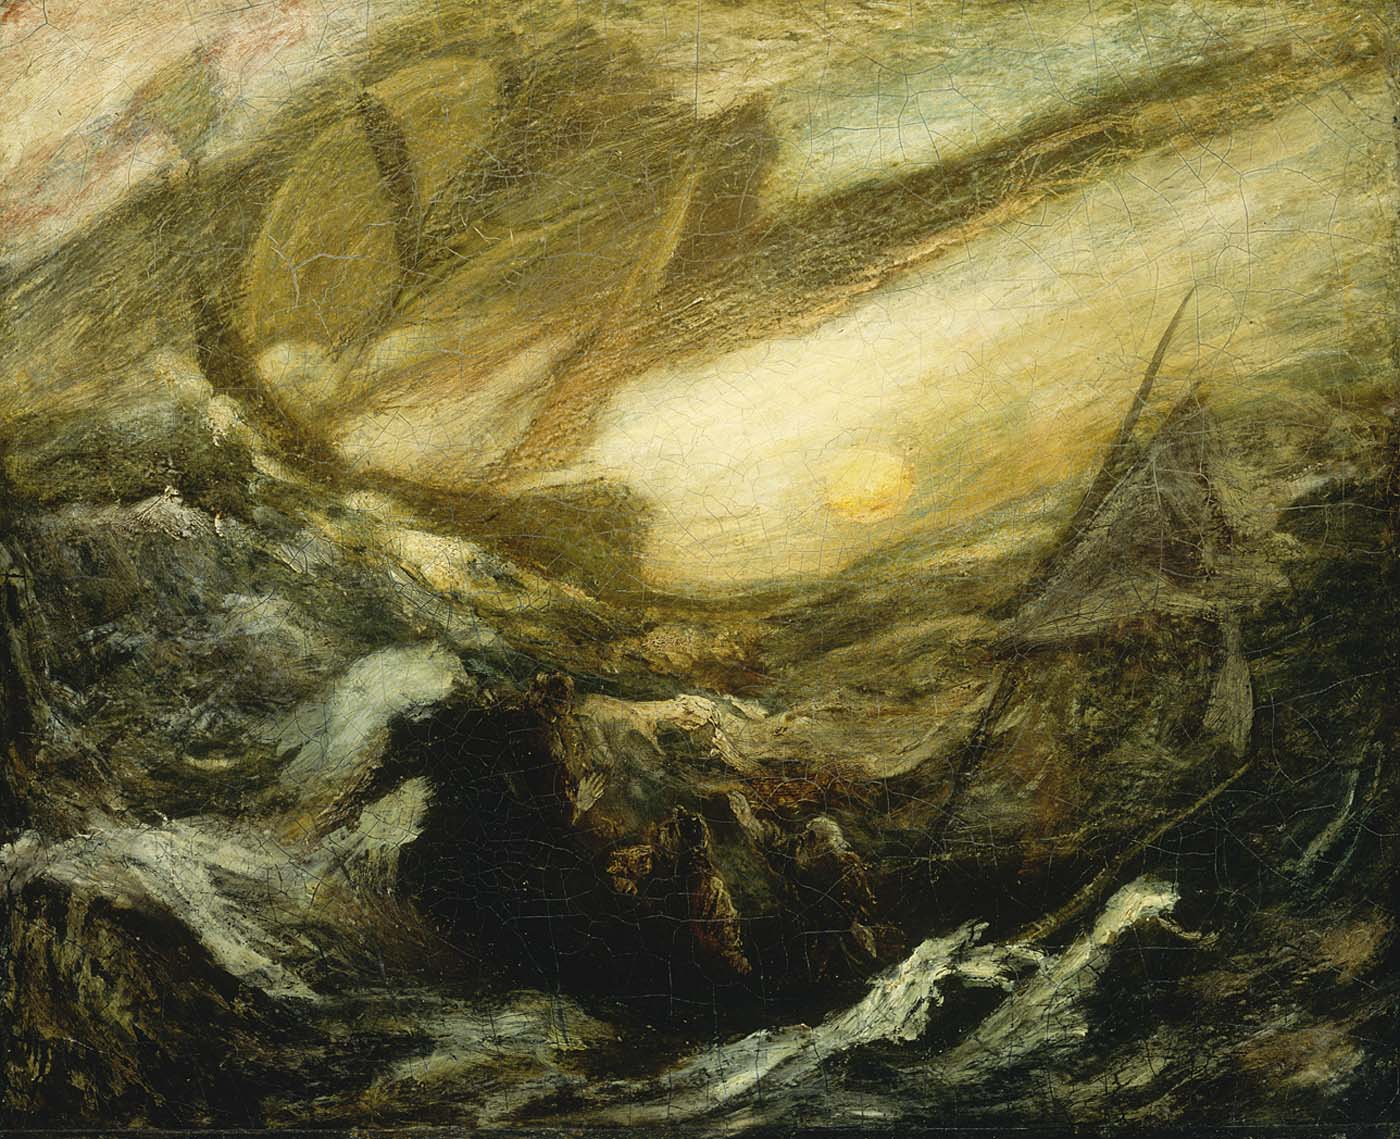What do you see when you zoom into the finer details of the painting? Zooming into the finer details of the painting reveals a rich tapestry of texture and subtle nuance. The artist's brushstrokes become more apparent, showcasing the technique and emotion poured into each stroke. You might notice hints of foam and spray at the crests of the waves, captured through vigorous, almost frantic lines. In the swirling clouds, there are layers of color blended to create a sense of depth and motion. Shadows and highlights interplay to suggest forms and shapes within the chaos—perhaps the faint outlines of distant ships or sea creatures. These details add layers of complexity to the scene, drawing the viewer deeper into the painting's tumultuous world. 